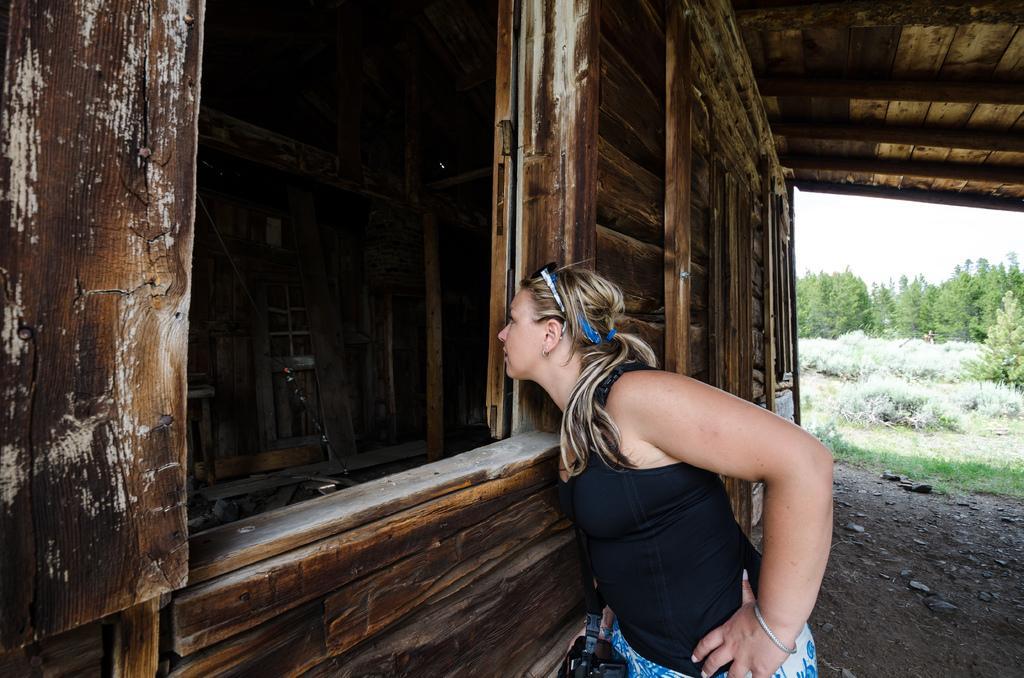In one or two sentences, can you explain what this image depicts? In this picture I can observe a woman in the middle of the picture. In front of her I can observe a house. In the background there are trees and sky. 